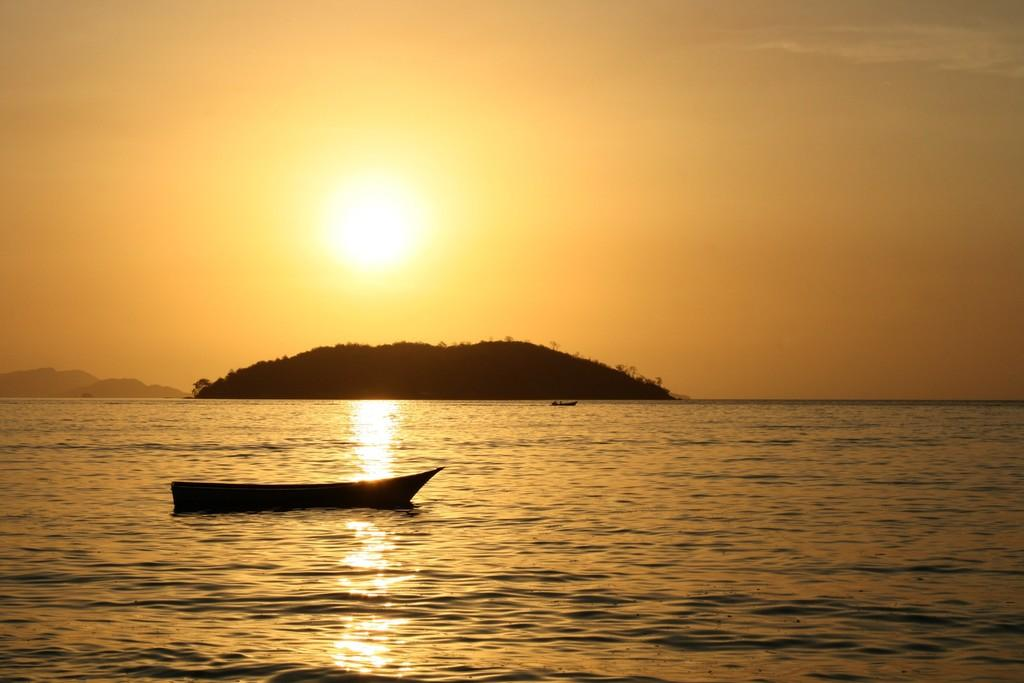What is the main subject in the foreground of the image? There is a boat in the foreground of the image. What is the boat's location in relation to the water? The boat is on the water. What can be seen in the background of the image? There is a cliff and mountains in the background of the image. What time of day is depicted in the image? The image depicts the dawn. What type of stitch is being used to sew the jellyfish in the image? There is no jellyfish present in the image, and therefore no stitching can be observed. 